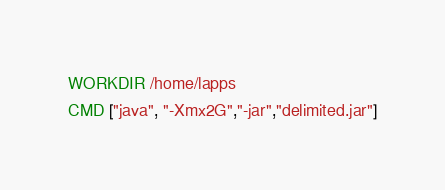Convert code to text. <code><loc_0><loc_0><loc_500><loc_500><_Dockerfile_>WORKDIR /home/lapps
CMD ["java", "-Xmx2G","-jar","delimited.jar"]
</code> 